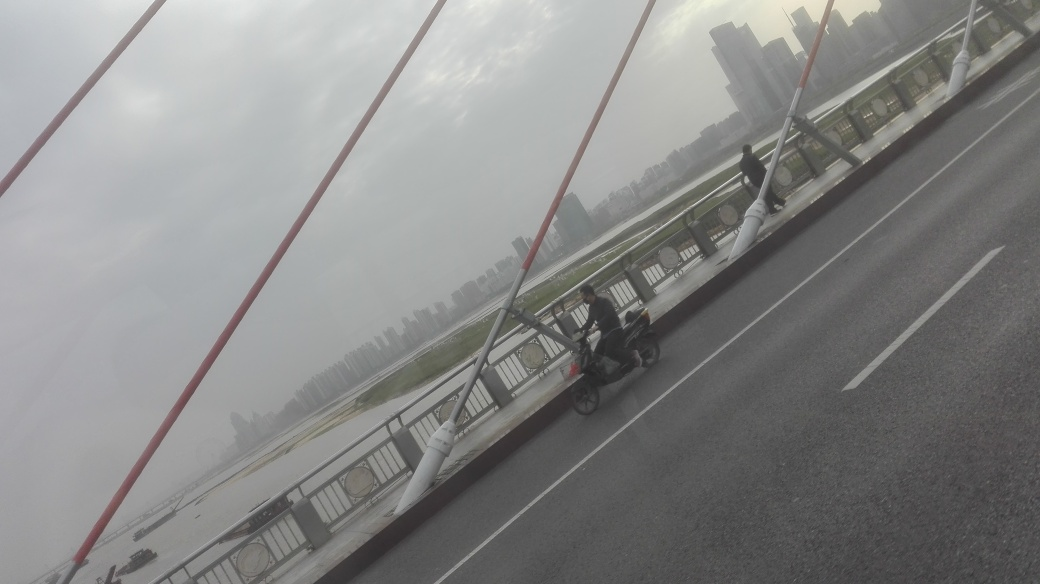Can you describe the surroundings visible in the image? Certainly! The image shows what appears to be an urban landscape viewed from a bridge, featuring a riverbank and possibly a city skyline shrouded in mist in the background. Does this setting look to be busy or more on the tranquil side? The setting has a tranquil vibe; there is minimal traffic on the bridge and the overcast weather imparts a quiet atmosphere to the scene. 